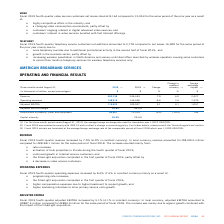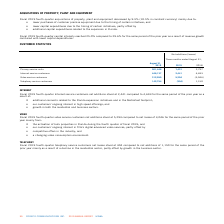According to Cogeco's financial document, What was the exchange rate in 2019? According to the financial document, 1.3222 USD/CDN. The relevant text states: "ge foreign exchange rate used for translation was 1.3222 USD/CDN...." Also, What was the exchange rate in 2018? According to the financial document, 1.3100 USD/CDN. The relevant text states: "of the comparable period of fiscal 2018 which was 1.3100 USD/CDN...." Also, What was the revenue increase in 2019? According to the financial document, 7.0%. The relevant text states: "Fiscal 2019 fourth-quarter revenue increased by 7.0% (6.0% in constant currency). In local currency, revenue amounted to US$199.5 million compared to US$..." Also, can you calculate: What was the increase / (decrease) in revenue from 2018 to 2019? Based on the calculation: 263,738 - 246,443, the result is 17295 (in thousands). This is based on the information: "Revenue 263,738 246,443 7.0 6.0 2,427 Revenue 263,738 246,443 7.0 6.0 2,427..." The key data points involved are: 246,443, 263,738. Also, can you calculate: What was the increase / (decrease) in operating expenses from 2018 to 2019? Based on the calculation: 148,215 - 136,506, the result is 11709 (in thousands). This is based on the information: "Operating expenses 148,215 136,506 8.6 7.6 1,370 Operating expenses 148,215 136,506 8.6 7.6 1,370..." The key data points involved are: 136,506, 148,215. Also, can you calculate: What was the average Adjusted EBITDA? To answer this question, I need to perform calculations using the financial data. The calculation is: (115,523 + 109,937) / 2, which equals 112730 (in thousands). This is based on the information: "Adjusted EBITDA 115,523 109,937 5.1 4.1 1,057 Adjusted EBITDA 115,523 109,937 5.1 4.1 1,057..." The key data points involved are: 109,937, 115,523. 